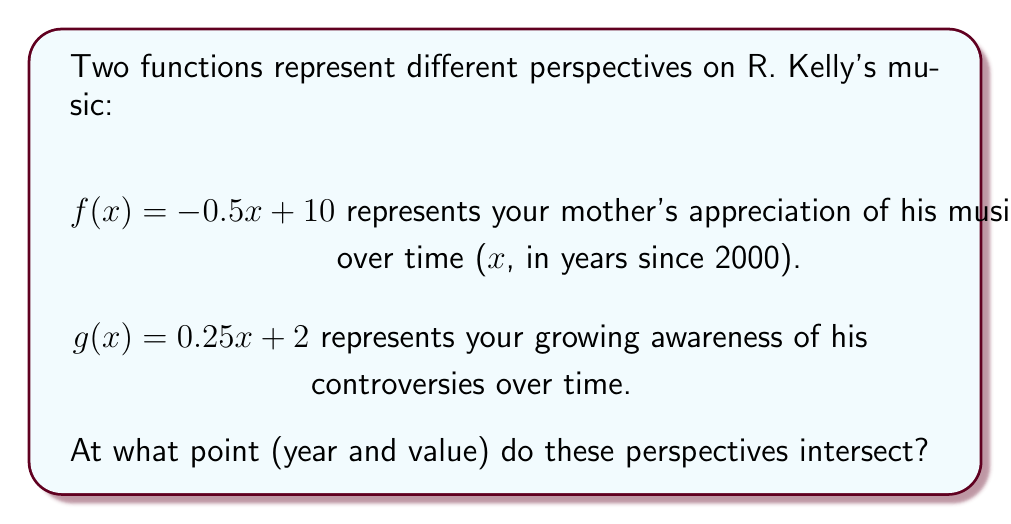Solve this math problem. To find the intersection point of these two functions, we need to solve the equation:

$f(x) = g(x)$

Substituting the given functions:

$-0.5x + 10 = 0.25x + 2$

Now, let's solve this equation step by step:

1) First, subtract 0.25x from both sides:
   $-0.75x + 10 = 2$

2) Subtract 2 from both sides:
   $-0.75x + 8 = 0$

3) Subtract 8 from both sides:
   $-0.75x = -8$

4) Divide both sides by -0.75:
   $x = \frac{-8}{-0.75} = \frac{32}{3} \approx 10.67$

This x-value represents the number of years since 2000. To find the actual year, add 2000:

Year = 2000 + $\frac{32}{3} \approx 2010.67$

To find the y-value at this intersection, we can use either function. Let's use $f(x)$:

$f(\frac{32}{3}) = -0.5(\frac{32}{3}) + 10 = -\frac{16}{3} + 10 = \frac{14}{3} \approx 4.67$

Therefore, the intersection point is $(\frac{32}{3}, \frac{14}{3})$ or approximately (10.67, 4.67).
Answer: $(\frac{32}{3}, \frac{14}{3})$, or (2010.67, 4.67) 